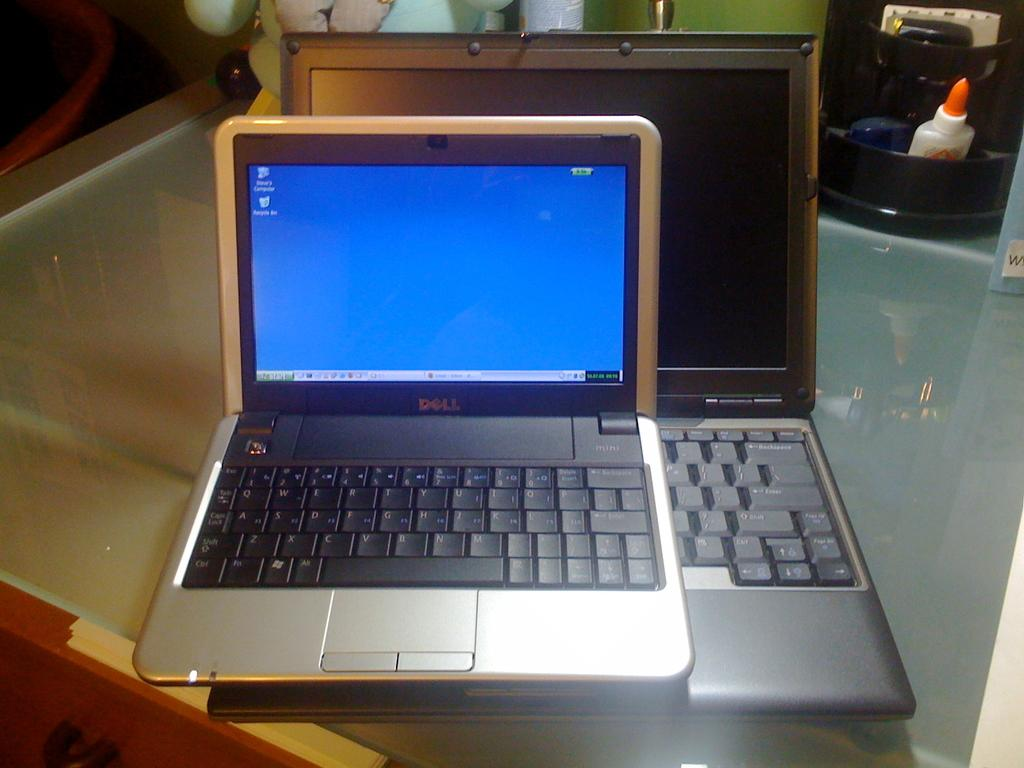<image>
Write a terse but informative summary of the picture. A small Dell laptop rests on top of a bigger laptop on a desk. 